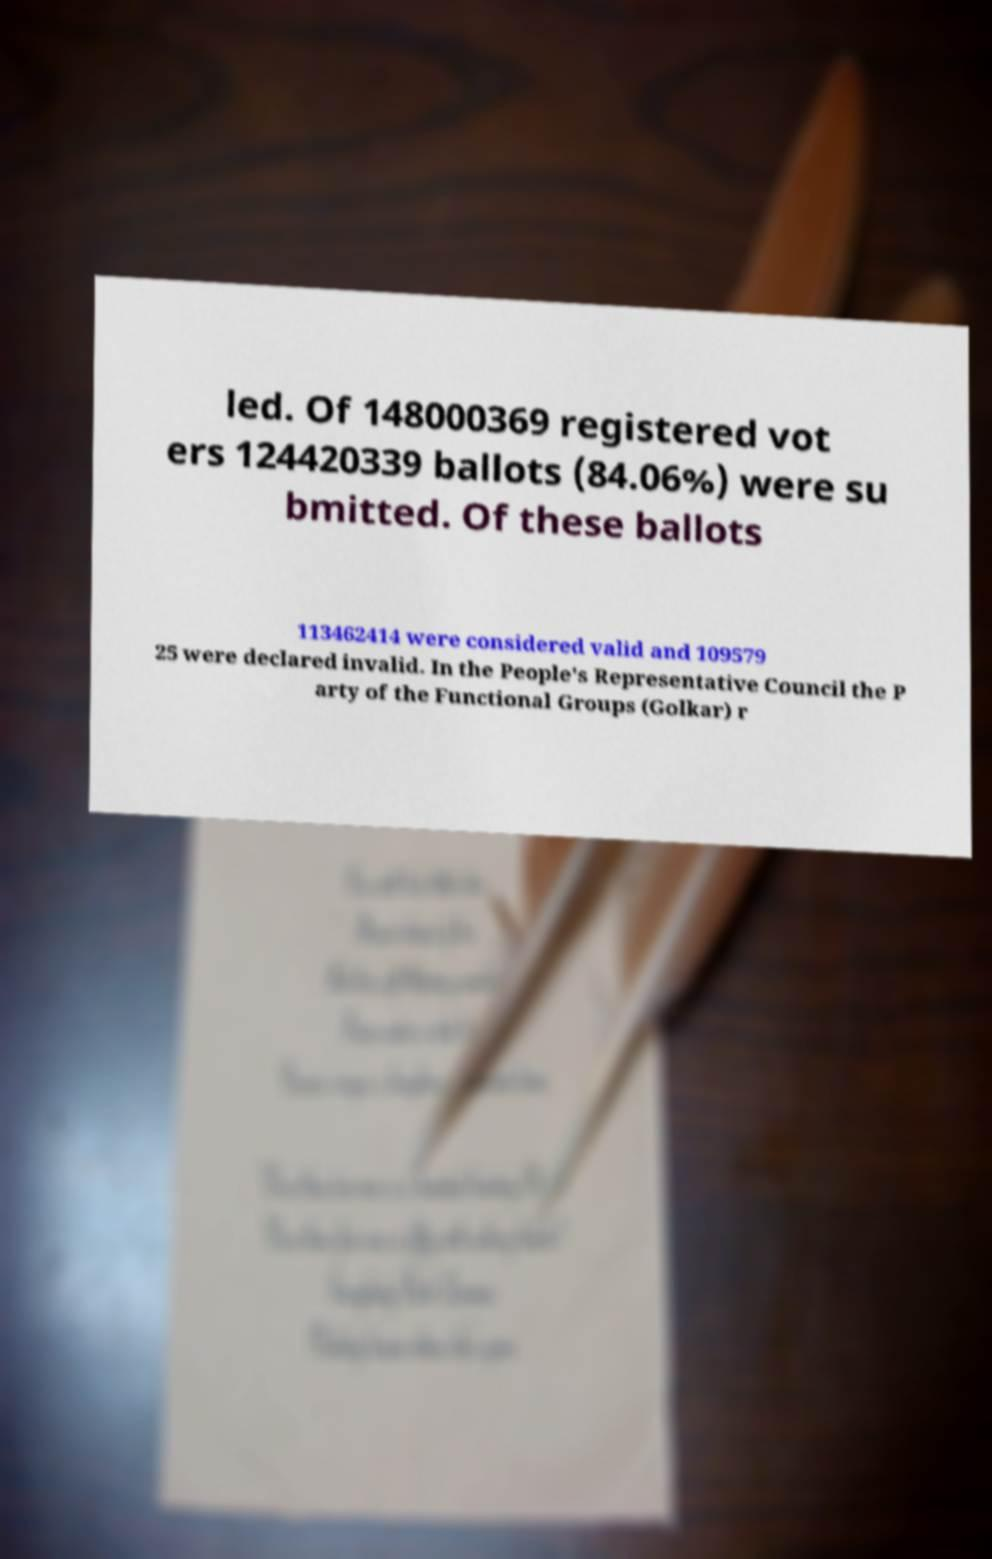Please read and relay the text visible in this image. What does it say? led. Of 148000369 registered vot ers 124420339 ballots (84.06%) were su bmitted. Of these ballots 113462414 were considered valid and 109579 25 were declared invalid. In the People's Representative Council the P arty of the Functional Groups (Golkar) r 